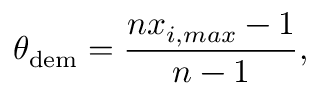Convert formula to latex. <formula><loc_0><loc_0><loc_500><loc_500>\theta _ { d e m } = \frac { n x _ { i , \max } - 1 } { n - 1 } ,</formula> 